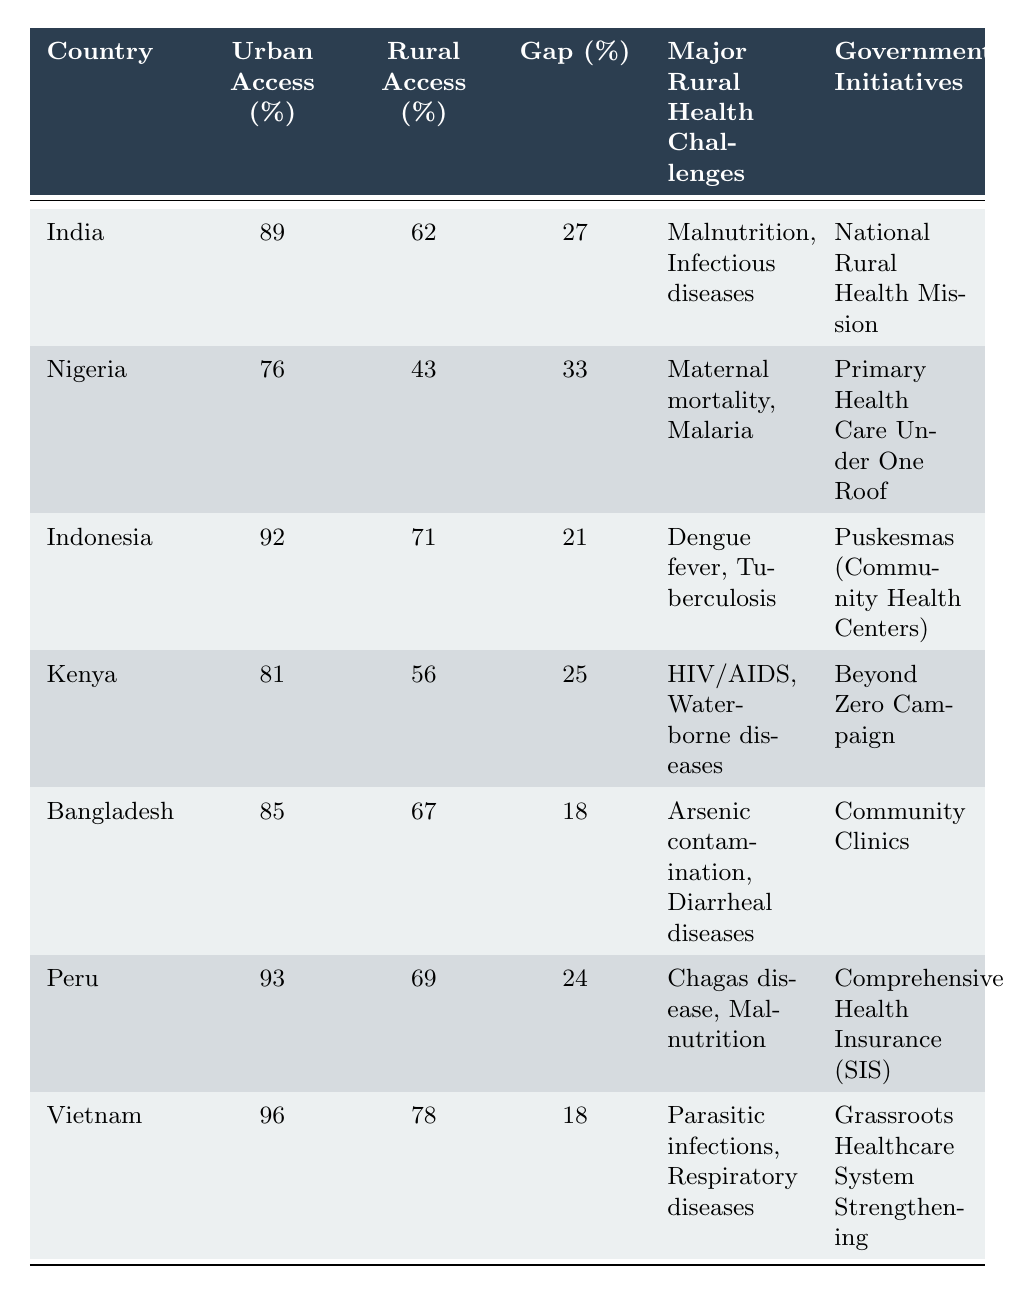What is the urban healthcare access percentage in India? According to the table, the value for urban healthcare access in India is directly listed under "Urban Healthcare Access (%)"
Answer: 89% What is the rural healthcare access percentage in Nigeria? The table provides the rural healthcare access percentage for Nigeria, which can be found under "Rural Healthcare Access (%)"
Answer: 43% Which country has the highest urban healthcare access percentage? By examining the "Urban Healthcare Access (%)" column, Vietnam shows the highest value at 96%
Answer: Vietnam What is the urban-rural gap for healthcare access in Kenya? The urban-rural gap for Kenya can be found in the "Urban-Rural Gap (%)" column, showing the difference in access percentages
Answer: 25% Which country experiences the major health challenge of maternal mortality? This information is under "Major Health Challenges in Rural Areas" for Nigeria, which explicitly mentions maternal mortality
Answer: Nigeria Is the urban-rural gap in Indonesia greater than that in Bangladesh? By comparing the urban-rural gaps listed for both countries, Indonesia has a gap of 21%, while Bangladesh has a gap of 18%. Therefore, Indonesia's gap is greater
Answer: Yes What is the average urban healthcare access percentage across all listed countries? To find the average, sum the urban healthcare access percentages (89 + 76 + 92 + 81 + 85 + 93 + 96 = 612) and divide by the number of countries (7), yielding an average of 87.43%
Answer: 87.43% Which countries have government initiatives specifically targeting rural health challenges? All listed countries have government initiatives; for example, India's initiative is "National Rural Health Mission," and Nigeria's is "Primary Health Care Under One Roof." All mention rural health initiatives
Answer: All countries listed Calculate the difference between the rural healthcare access percentages of India and Peru. The rural access percentage for India is 62%, and for Peru, it is 69%. The difference is calculated as 69 - 62 = 7%
Answer: 7% Which country has the smallest urban-rural gap according to the data? Reviewing the "Urban-Rural Gap (%)" column, Bangladesh has the smallest gap of 18%
Answer: Bangladesh 